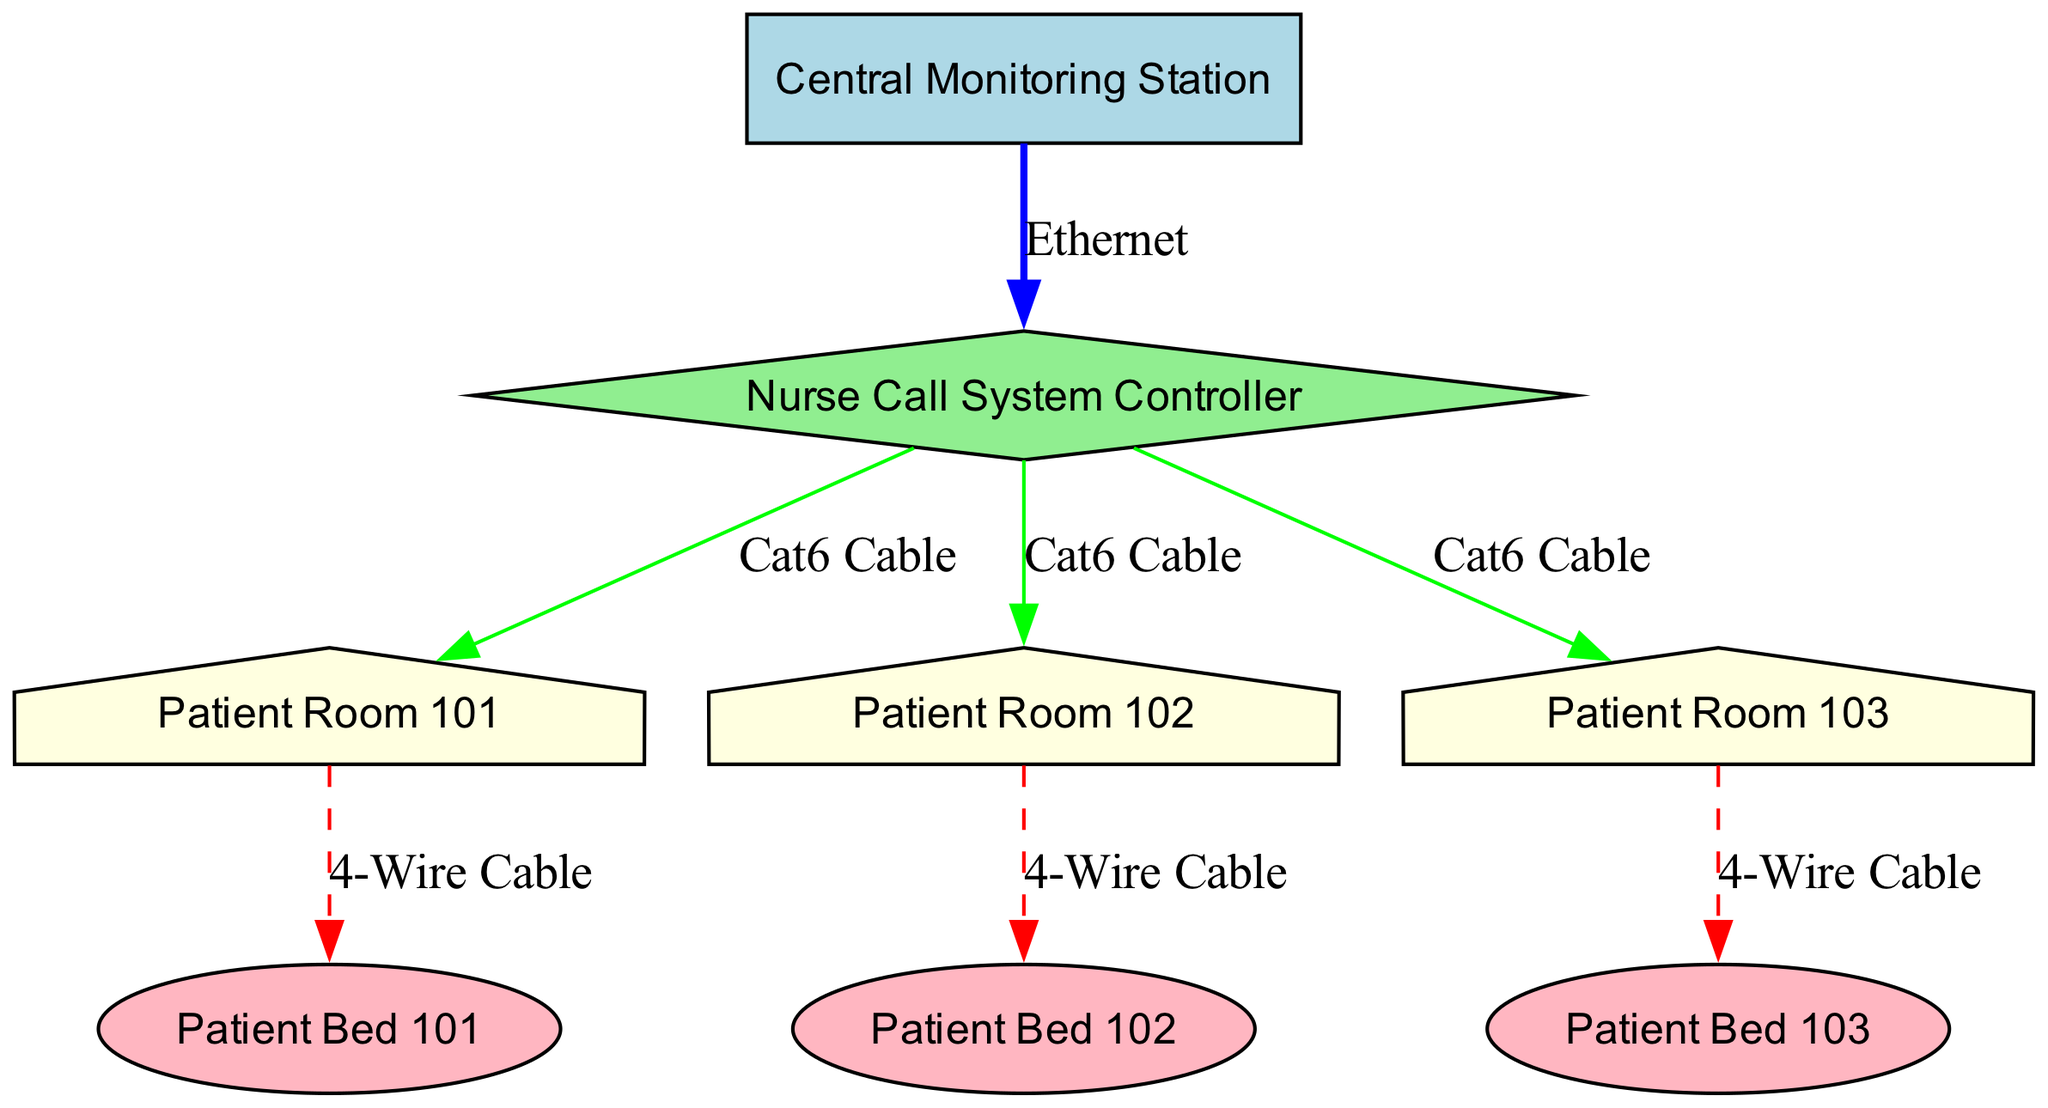What is the label of the node that represents the Central Monitoring Station? The node labeled "CMS" represents the Central Monitoring Station, as indicated in the "nodes" data.
Answer: Central Monitoring Station How many patient rooms are depicted in the diagram? The diagram lists three patient rooms identified by "PR1," "PR2," and "PR3," which can be counted directly from the "nodes" section.
Answer: 3 What type of cable is used to connect the Nurse Call System Controller to the patient rooms? The connection from the Nurse Call System Controller (NCS) to each of the patient rooms (PR1, PR2, PR3) is labeled as "Cat6 Cable," and this can be confirmed in the "edges" section of the data.
Answer: Cat6 Cable Which patient bed is connected to Patient Room 103? The edge connects Patient Room 103 (PR3) to Patient Bed 103 (PB3), which can be seen in the "edges" data reflecting the specific association.
Answer: Patient Bed 103 What is the total number of edges in the diagram? By reviewing the "edges" data which contain seven connections, we can determine the total number of edges.
Answer: 7 What is the color of the Nurse Call System Controller node in the diagram? The Nurse Call System Controller (NCS) node is represented with a fill color of "lightgreen," specified in the node style definitions.
Answer: lightgreen What type of connection is between the Central Monitoring Station and the Nurse Call System Controller? The connection from the Central Monitoring Station (CMS) to the Nurse Call System Controller (NCS) is labeled as "Ethernet," as can be seen in the edges data.
Answer: Ethernet How many types of cables are shown in the diagram? The cables shown include "Ethernet," "Cat6 Cable," and "4-Wire Cable," which can be counted by examining the different labels in the edges section.
Answer: 3 What shape is used to represent the Patient Rooms in the diagram? The Patient Rooms (PR1, PR2, PR3) are represented as "house" shapes, as specified in the node attributes.
Answer: house 